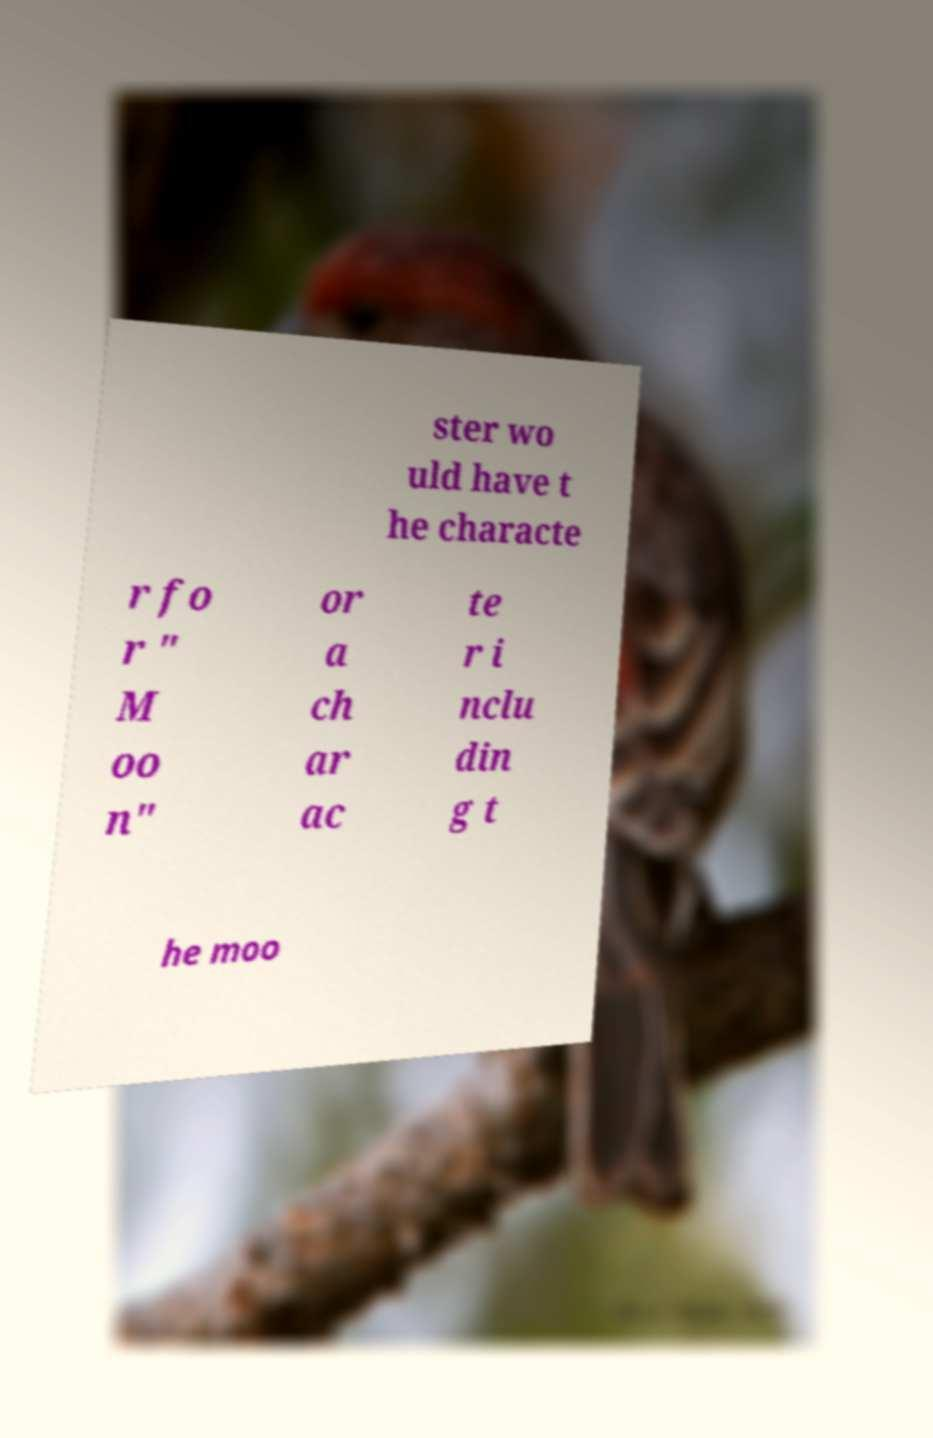I need the written content from this picture converted into text. Can you do that? ster wo uld have t he characte r fo r " M oo n" or a ch ar ac te r i nclu din g t he moo 